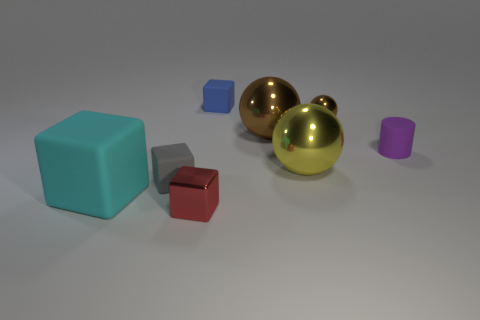There is a large thing that is left of the blue thing; what color is it?
Offer a very short reply. Cyan. What material is the tiny cube that is both in front of the blue rubber cube and behind the small red cube?
Offer a very short reply. Rubber. There is a brown object left of the small brown object; how many small red blocks are to the left of it?
Ensure brevity in your answer.  1. What is the shape of the purple thing?
Offer a terse response. Cylinder. What shape is the tiny red object that is the same material as the small sphere?
Give a very brief answer. Cube. Is the shape of the brown metallic thing that is to the left of the yellow metal thing the same as  the gray thing?
Give a very brief answer. No. What is the shape of the tiny metal object that is in front of the big cyan object?
Your answer should be compact. Cube. How many gray rubber blocks are the same size as the red block?
Give a very brief answer. 1. What color is the big rubber block?
Your response must be concise. Cyan. Do the cylinder and the metal object that is left of the large brown metal sphere have the same color?
Ensure brevity in your answer.  No. 